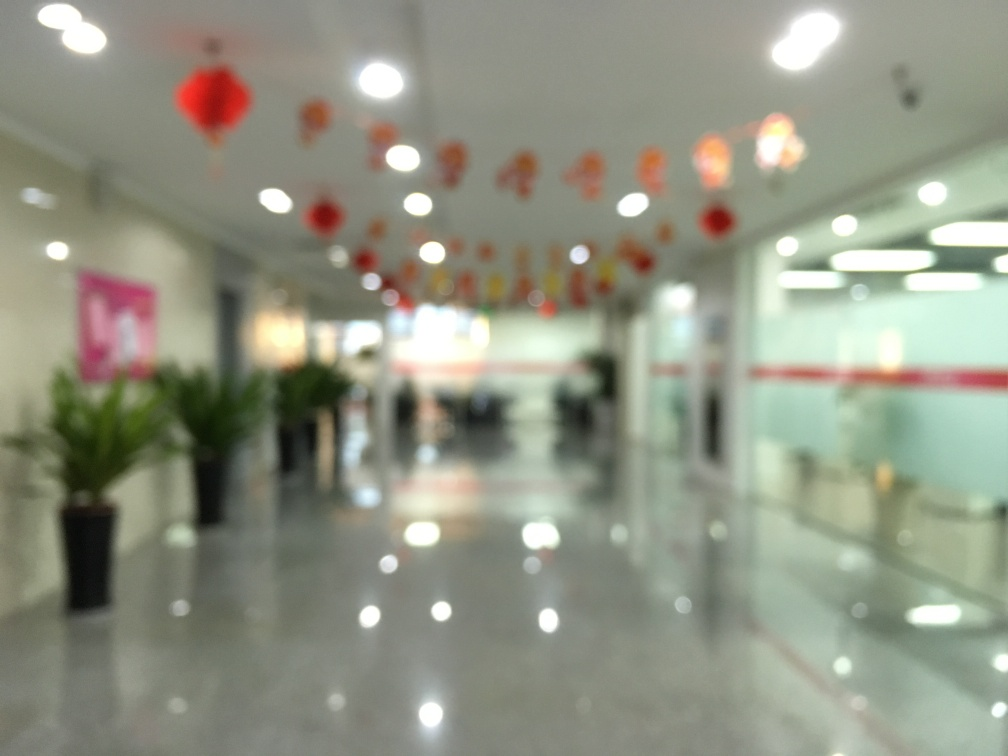Are there any quality issues with this image? Yes, the image is out of focus, which obscures the details of the space. The blurriness prevents a clear view of the decorations and objects inside the room, such as the red lanterns, potted plants, and furniture. 